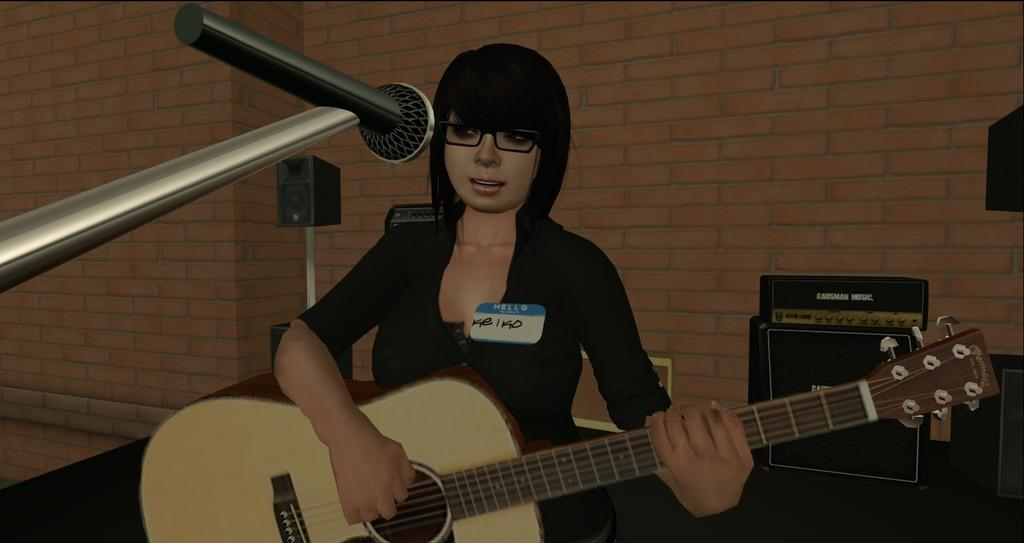What type of character is in the image? There is a cartoon character in the image. What is the cartoon character holding? The cartoon character is holding a guitar. What equipment is present in the image for amplifying sound? There is a microphone and a speaker in the image. What type of machine is in the image? There is a machine in the image. How many apples are on the cartoon character's head in the image? There are no apples present on the cartoon character's head in the image. What type of marble is used to create the microphone in the image? There is no marble used in the microphone in the image, as it is an electronic device. 